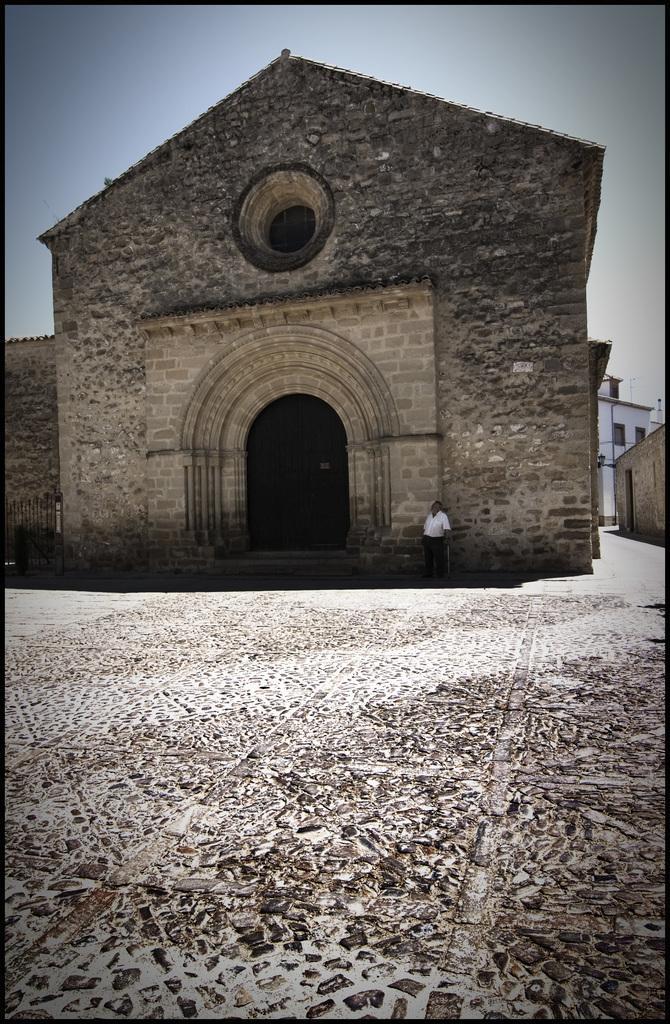Describe this image in one or two sentences. In this image in the center there are buildings and in the front there is a man standing. 